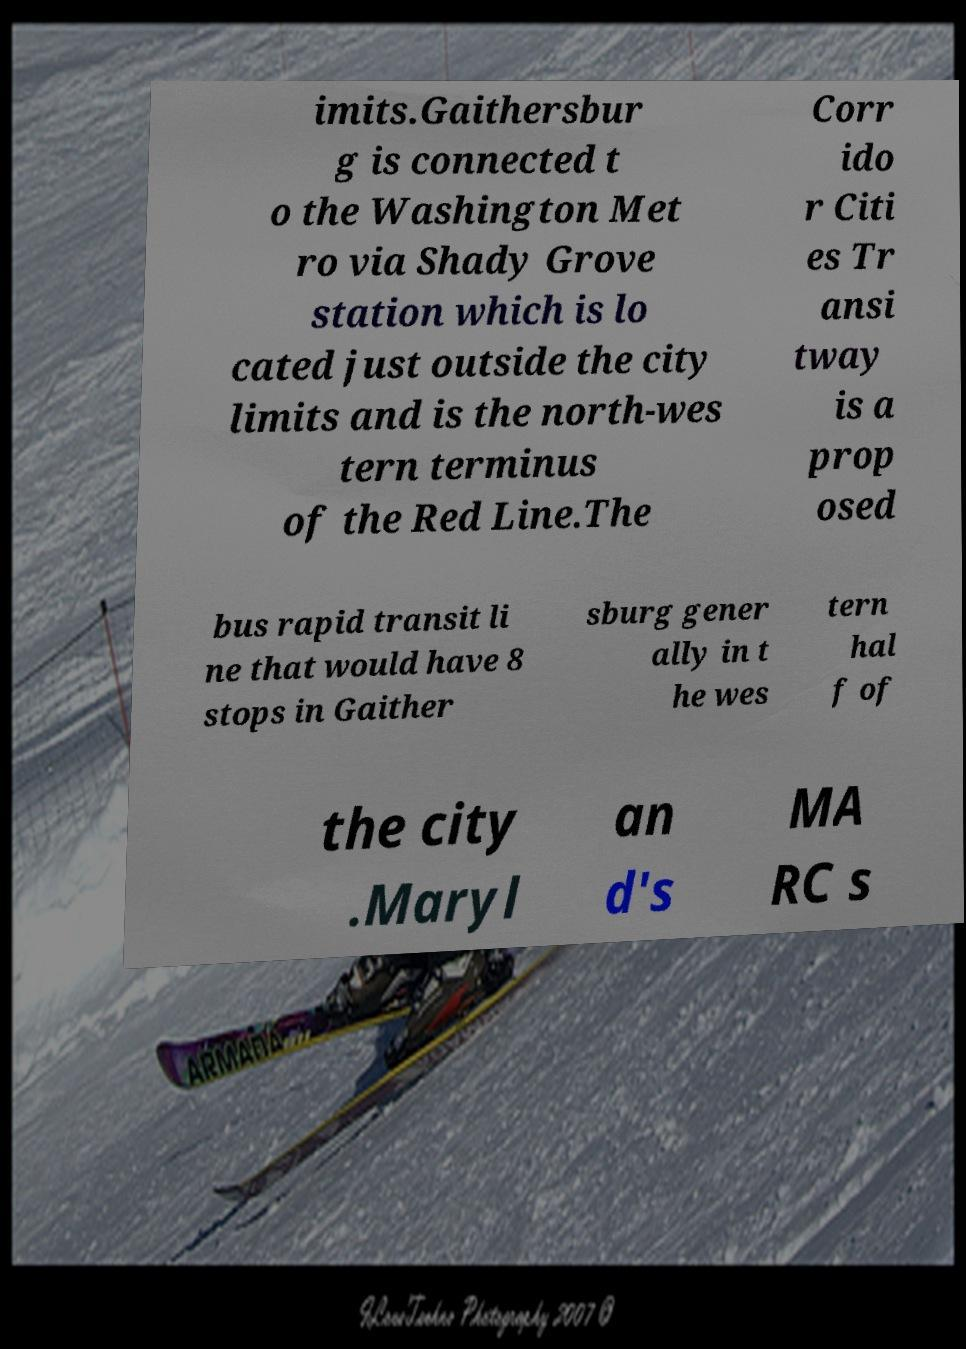Please identify and transcribe the text found in this image. imits.Gaithersbur g is connected t o the Washington Met ro via Shady Grove station which is lo cated just outside the city limits and is the north-wes tern terminus of the Red Line.The Corr ido r Citi es Tr ansi tway is a prop osed bus rapid transit li ne that would have 8 stops in Gaither sburg gener ally in t he wes tern hal f of the city .Maryl an d's MA RC s 